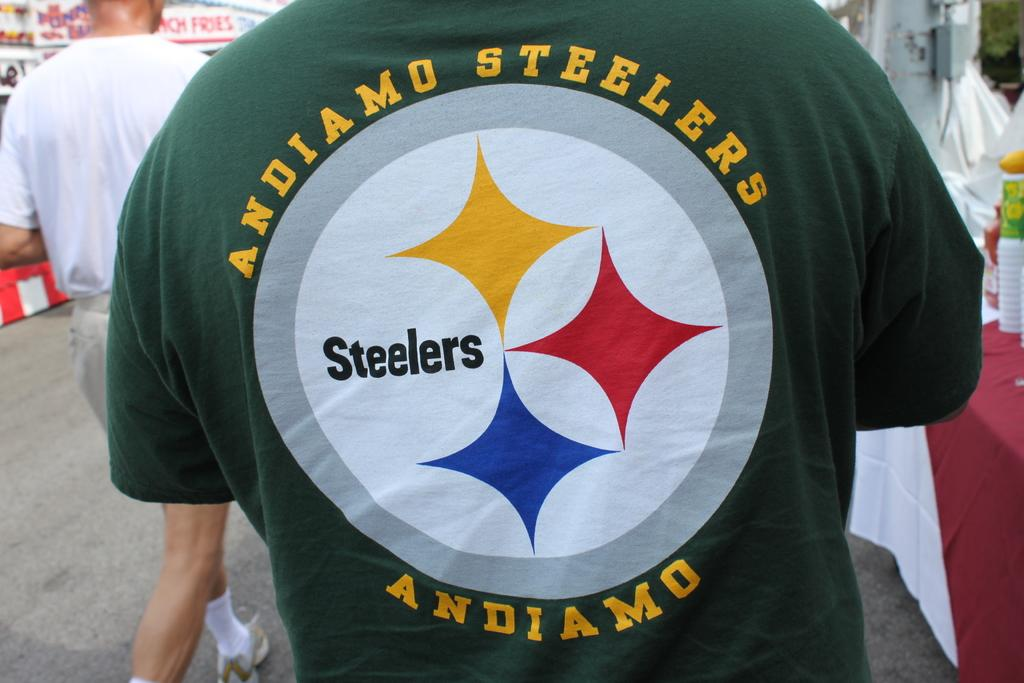<image>
Create a compact narrative representing the image presented. A man's t-shirt shows support for the Steelers and urges them on in Italian. 